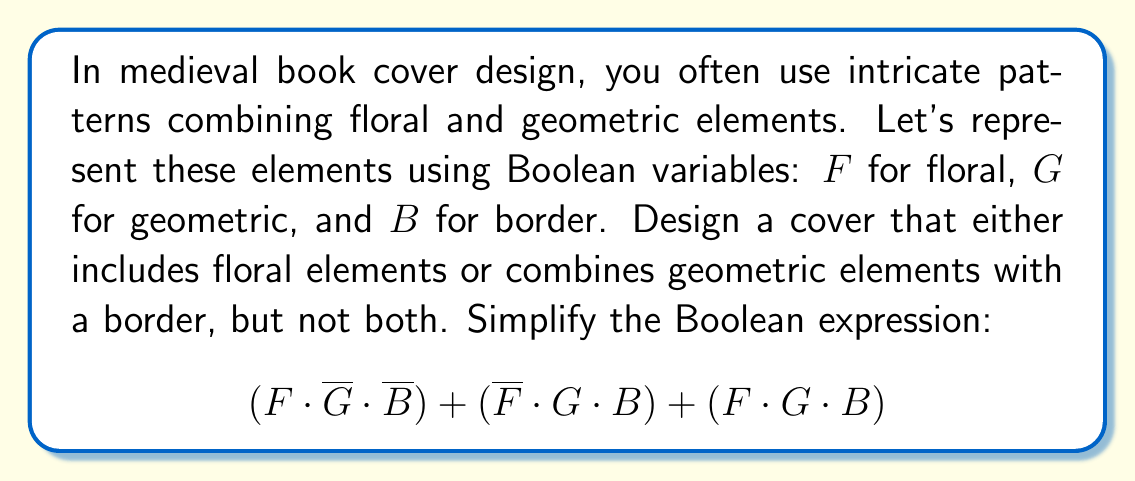Could you help me with this problem? Let's simplify this Boolean expression step-by-step:

1) First, let's distribute the $F$ in the last term:
   $$(F \cdot \overline{G} \cdot \overline{B}) + (\overline{F} \cdot G \cdot B) + (F \cdot G \cdot B)$$
   $$= (F \cdot \overline{G} \cdot \overline{B}) + (\overline{F} \cdot G \cdot B) + (F \cdot G \cdot B)$$

2) Now, we can combine the last two terms using the absorption law:
   $$= (F \cdot \overline{G} \cdot \overline{B}) + (G \cdot B)$$

3) We can't simplify further using Boolean algebra laws. However, looking at the problem statement, we want either floral elements $(F)$ or geometric elements with a border $(G \cdot B)$, but not both. This is the definition of the XOR operation $(\oplus)$.

4) Therefore, our final simplified expression is:
   $$F \oplus (G \cdot B)$$

This Boolean expression represents a design that either includes floral elements or combines geometric elements with a border, but not both, which aligns with the intricate medieval design pattern described in the question.
Answer: $F \oplus (G \cdot B)$ 